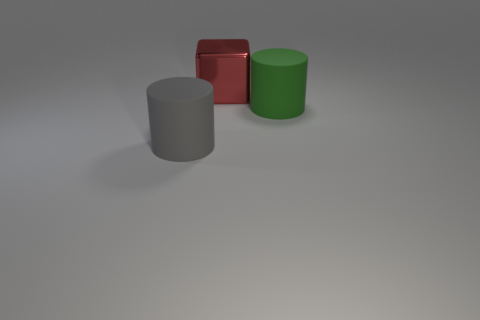Add 1 big things. How many objects exist? 4 Subtract all green cylinders. How many cylinders are left? 1 Subtract 1 cubes. How many cubes are left? 0 Subtract 0 purple cylinders. How many objects are left? 3 Subtract all cubes. How many objects are left? 2 Subtract all red cylinders. Subtract all purple cubes. How many cylinders are left? 2 Subtract all large yellow objects. Subtract all big cylinders. How many objects are left? 1 Add 3 blocks. How many blocks are left? 4 Add 3 big cylinders. How many big cylinders exist? 5 